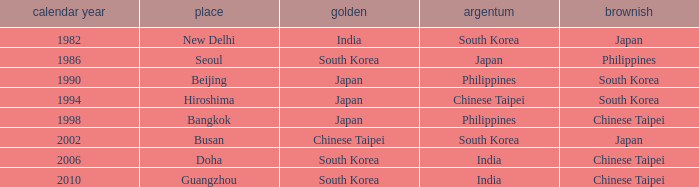Which Bronze has a Year smaller than 1994, and a Silver of south korea? Japan. 